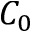<formula> <loc_0><loc_0><loc_500><loc_500>C _ { 0 }</formula> 